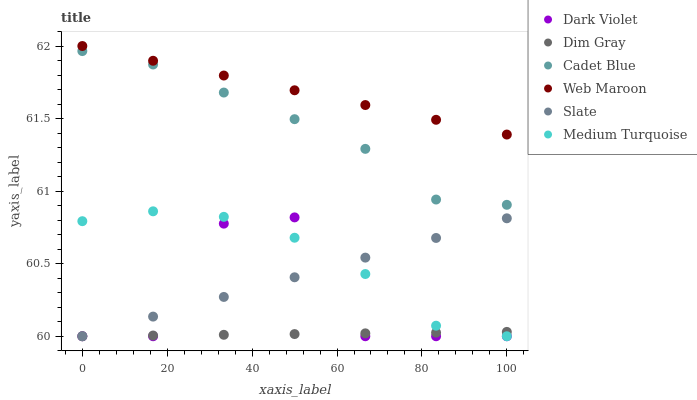Does Dim Gray have the minimum area under the curve?
Answer yes or no. Yes. Does Web Maroon have the maximum area under the curve?
Answer yes or no. Yes. Does Slate have the minimum area under the curve?
Answer yes or no. No. Does Slate have the maximum area under the curve?
Answer yes or no. No. Is Web Maroon the smoothest?
Answer yes or no. Yes. Is Dark Violet the roughest?
Answer yes or no. Yes. Is Slate the smoothest?
Answer yes or no. No. Is Slate the roughest?
Answer yes or no. No. Does Slate have the lowest value?
Answer yes or no. Yes. Does Web Maroon have the lowest value?
Answer yes or no. No. Does Web Maroon have the highest value?
Answer yes or no. Yes. Does Slate have the highest value?
Answer yes or no. No. Is Dark Violet less than Web Maroon?
Answer yes or no. Yes. Is Web Maroon greater than Cadet Blue?
Answer yes or no. Yes. Does Slate intersect Dim Gray?
Answer yes or no. Yes. Is Slate less than Dim Gray?
Answer yes or no. No. Is Slate greater than Dim Gray?
Answer yes or no. No. Does Dark Violet intersect Web Maroon?
Answer yes or no. No. 